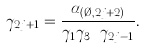<formula> <loc_0><loc_0><loc_500><loc_500>\gamma _ { 2 j + 1 } = \frac { \alpha _ { ( \emptyset , 2 j + 2 ) } } { \gamma _ { 1 } \gamma _ { 3 } \cdots \gamma _ { 2 j - 1 } } .</formula> 